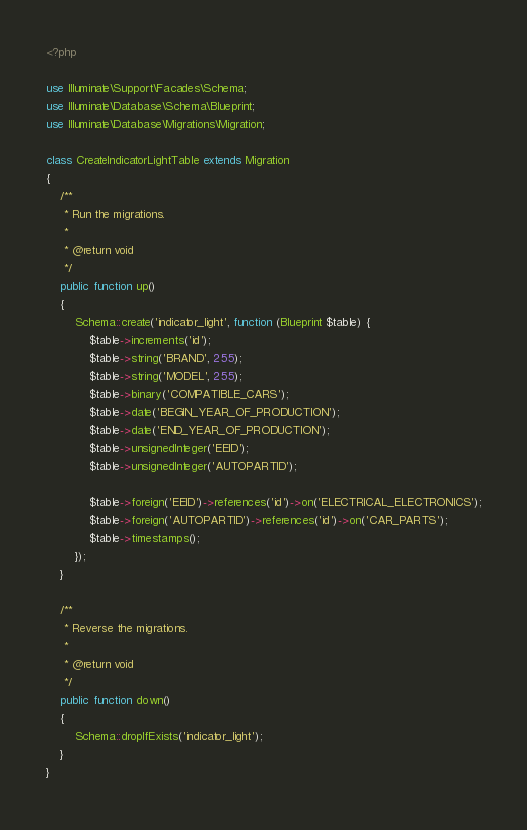Convert code to text. <code><loc_0><loc_0><loc_500><loc_500><_PHP_><?php

use Illuminate\Support\Facades\Schema;
use Illuminate\Database\Schema\Blueprint;
use Illuminate\Database\Migrations\Migration;

class CreateIndicatorLightTable extends Migration
{
    /**
     * Run the migrations.
     *
     * @return void
     */
    public function up()
    {
        Schema::create('indicator_light', function (Blueprint $table) {
            $table->increments('id');
            $table->string('BRAND', 255);
            $table->string('MODEL', 255);
            $table->binary('COMPATIBLE_CARS');
            $table->date('BEGIN_YEAR_OF_PRODUCTION');
            $table->date('END_YEAR_OF_PRODUCTION');
            $table->unsignedInteger('EEID');
            $table->unsignedInteger('AUTOPARTID');
            
            $table->foreign('EEID')->references('id')->on('ELECTRICAL_ELECTRONICS');
            $table->foreign('AUTOPARTID')->references('id')->on('CAR_PARTS');
            $table->timestamps();
        });
    }

    /**
     * Reverse the migrations.
     *
     * @return void
     */
    public function down()
    {
        Schema::dropIfExists('indicator_light');
    }
}
</code> 